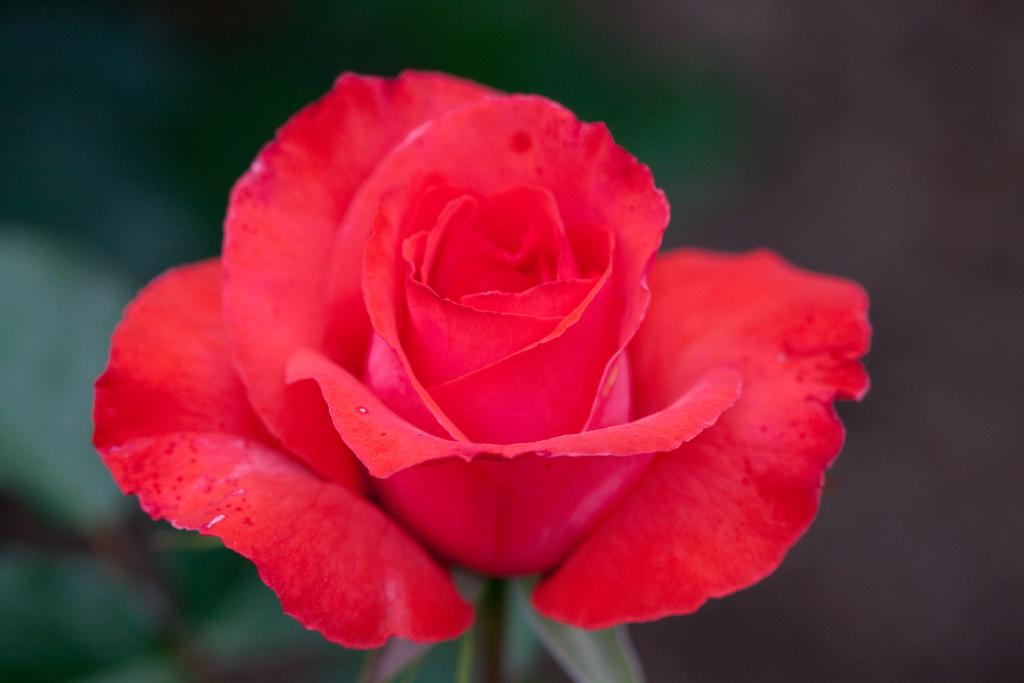What type of flower is in the image? There is a red color rose flower in the image. Can you describe the background of the image? The background of the image is blurred. What type of goat can be seen reacting to the battle in the image? There is no goat or battle present in the image; it features a red color rose flower with a blurred background. 